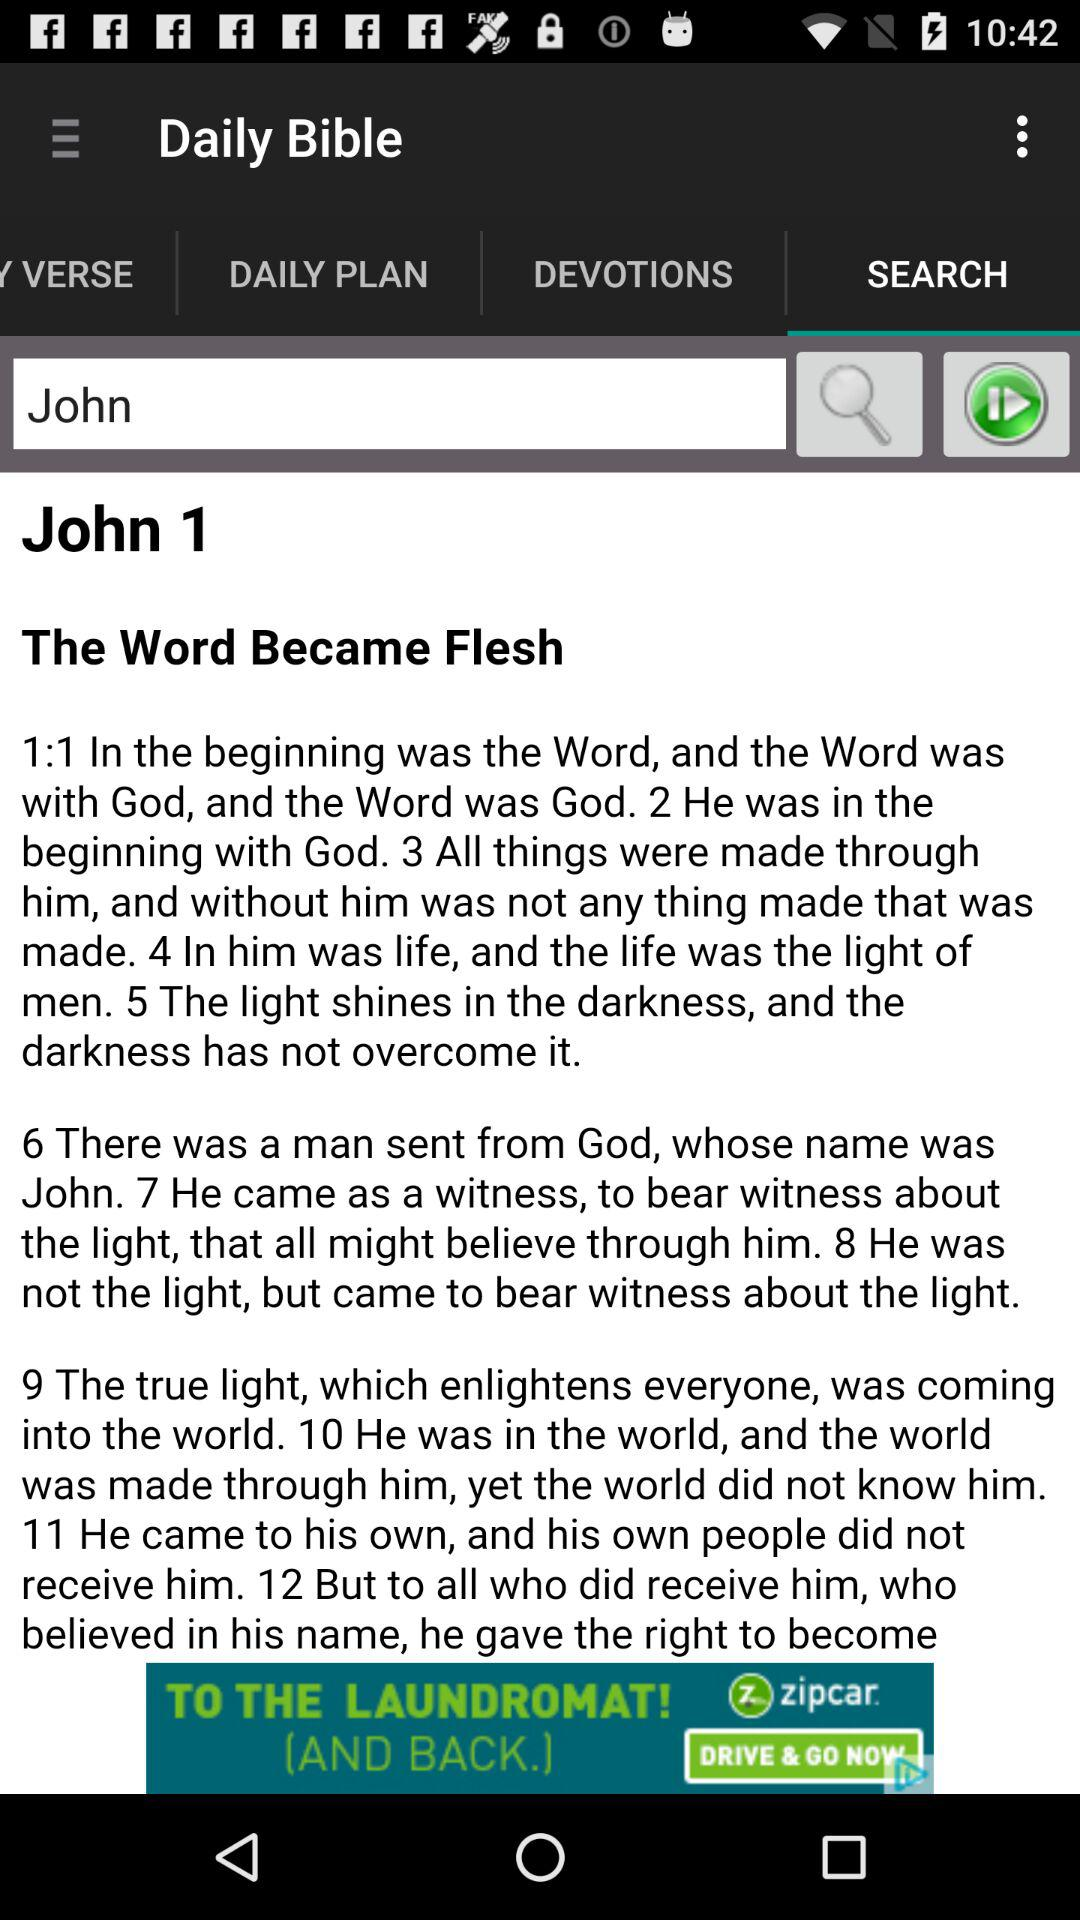Who sent John? John was sent by God. 